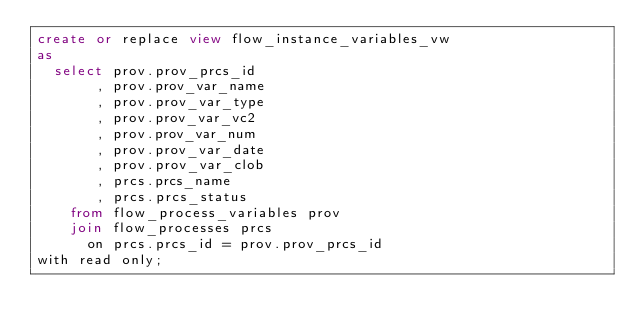<code> <loc_0><loc_0><loc_500><loc_500><_SQL_>create or replace view flow_instance_variables_vw
as
  select prov.prov_prcs_id
       , prov.prov_var_name
       , prov.prov_var_type
       , prov.prov_var_vc2
       , prov.prov_var_num
       , prov.prov_var_date
       , prov.prov_var_clob
       , prcs.prcs_name
       , prcs.prcs_status
    from flow_process_variables prov
    join flow_processes prcs
      on prcs.prcs_id = prov.prov_prcs_id
with read only;
</code> 